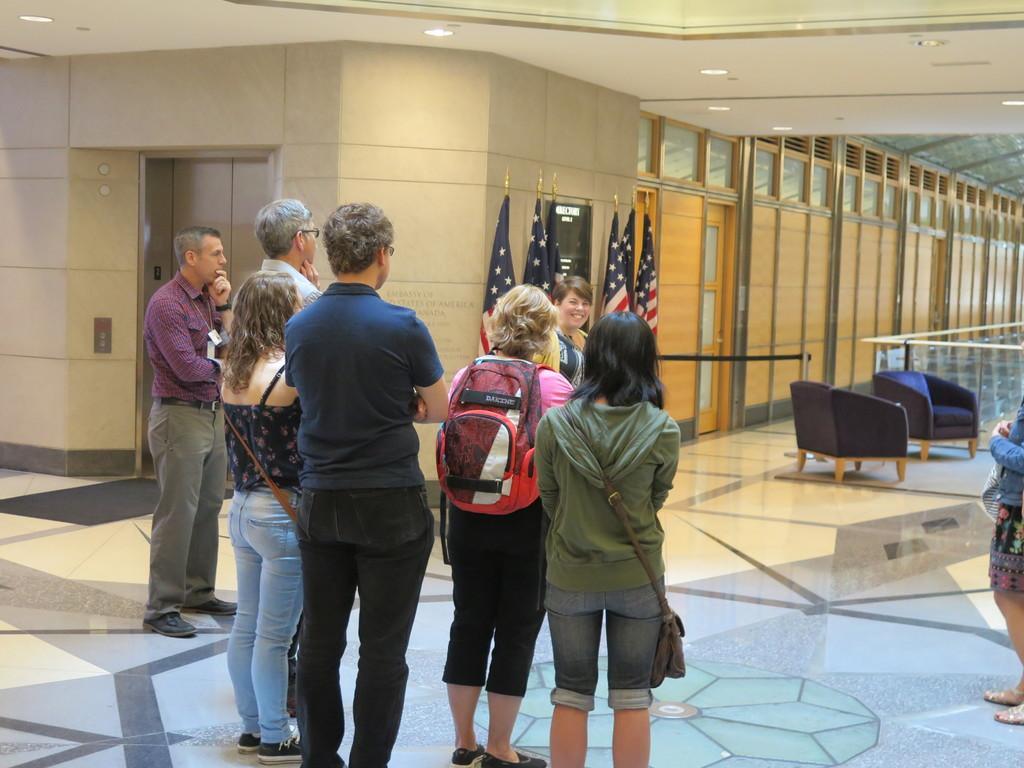Please provide a concise description of this image. Here we can see people, flags, door and board. This person wore a bag. Lights are attached to the ceiling. This is an elevator. 